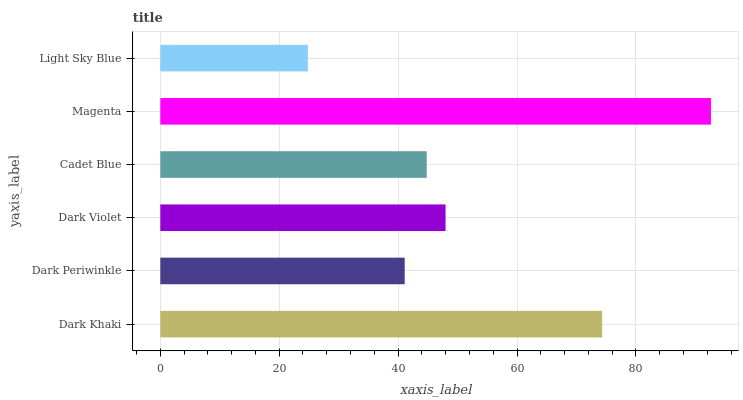Is Light Sky Blue the minimum?
Answer yes or no. Yes. Is Magenta the maximum?
Answer yes or no. Yes. Is Dark Periwinkle the minimum?
Answer yes or no. No. Is Dark Periwinkle the maximum?
Answer yes or no. No. Is Dark Khaki greater than Dark Periwinkle?
Answer yes or no. Yes. Is Dark Periwinkle less than Dark Khaki?
Answer yes or no. Yes. Is Dark Periwinkle greater than Dark Khaki?
Answer yes or no. No. Is Dark Khaki less than Dark Periwinkle?
Answer yes or no. No. Is Dark Violet the high median?
Answer yes or no. Yes. Is Cadet Blue the low median?
Answer yes or no. Yes. Is Cadet Blue the high median?
Answer yes or no. No. Is Dark Violet the low median?
Answer yes or no. No. 